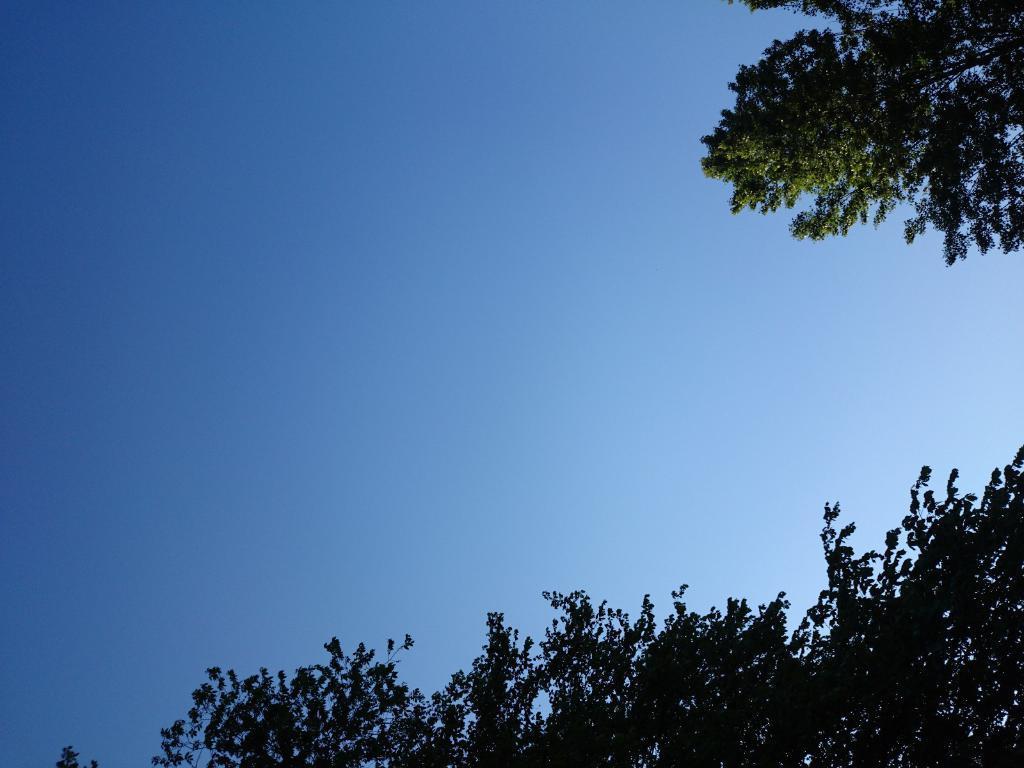Could you give a brief overview of what you see in this image? At the bottom there are branches of a tree. On the right there are branches of a tree. In this picture there is sky, sky is clear. 